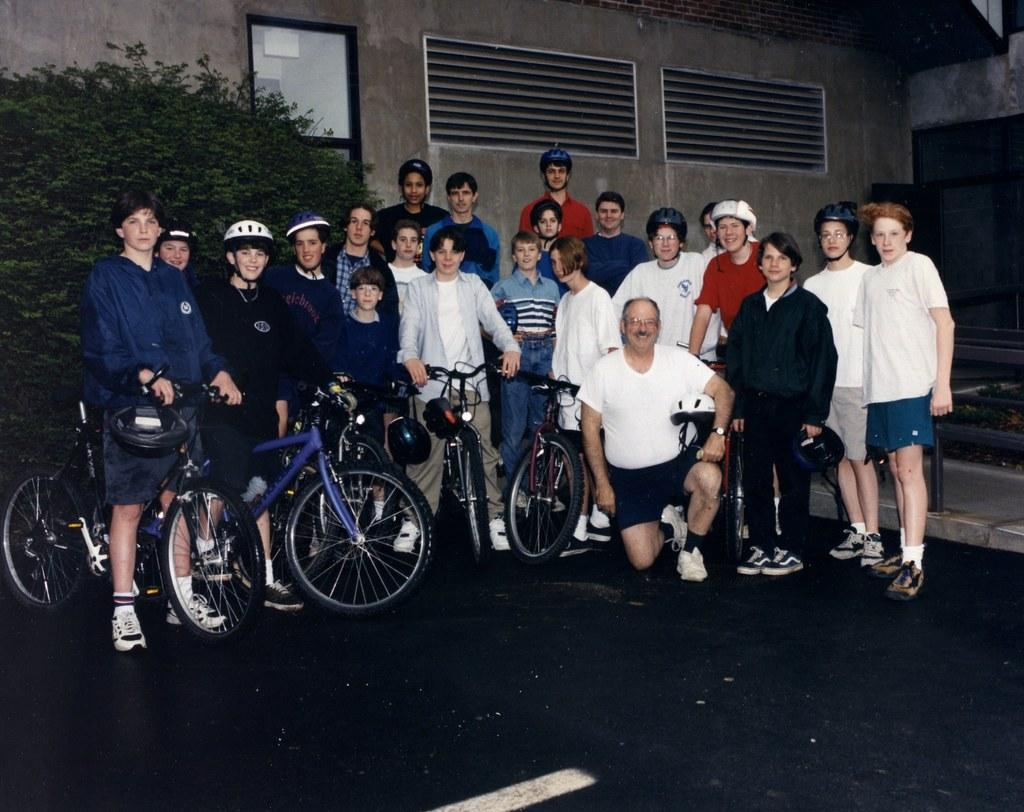How many people are in the image? There is a group of people in the image. What are the people in the image doing? The people are posing for a camera. What else can be seen in the image besides the people? There are bicycles in the image. What type of wristwatch is the goat wearing in the image? There is no goat present in the image, and therefore no wristwatch can be observed. 